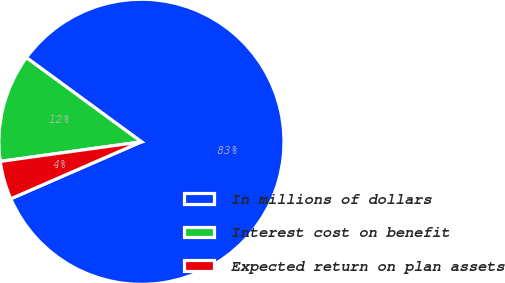<chart> <loc_0><loc_0><loc_500><loc_500><pie_chart><fcel>In millions of dollars<fcel>Interest cost on benefit<fcel>Expected return on plan assets<nl><fcel>83.4%<fcel>12.25%<fcel>4.35%<nl></chart> 